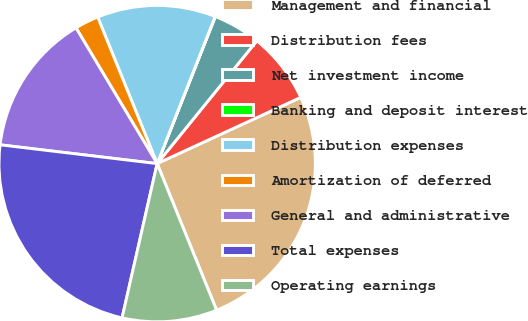Convert chart. <chart><loc_0><loc_0><loc_500><loc_500><pie_chart><fcel>Management and financial<fcel>Distribution fees<fcel>Net investment income<fcel>Banking and deposit interest<fcel>Distribution expenses<fcel>Amortization of deferred<fcel>General and administrative<fcel>Total expenses<fcel>Operating earnings<nl><fcel>25.75%<fcel>7.27%<fcel>4.86%<fcel>0.02%<fcel>12.11%<fcel>2.44%<fcel>14.53%<fcel>23.34%<fcel>9.69%<nl></chart> 